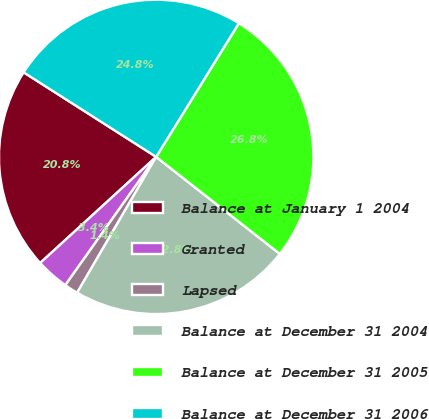<chart> <loc_0><loc_0><loc_500><loc_500><pie_chart><fcel>Balance at January 1 2004<fcel>Granted<fcel>Lapsed<fcel>Balance at December 31 2004<fcel>Balance at December 31 2005<fcel>Balance at December 31 2006<nl><fcel>20.83%<fcel>3.4%<fcel>1.42%<fcel>22.8%<fcel>26.76%<fcel>24.78%<nl></chart> 